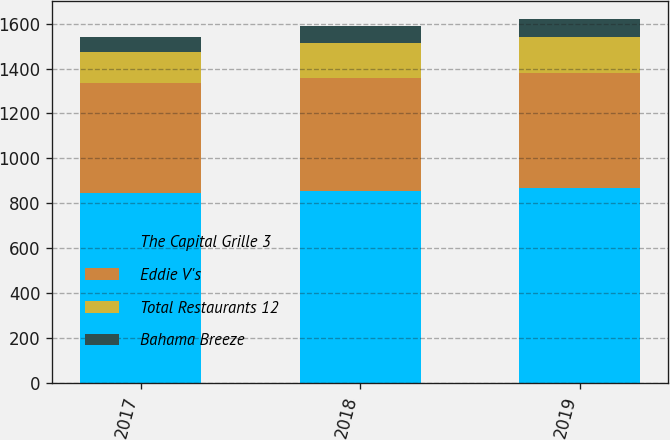<chart> <loc_0><loc_0><loc_500><loc_500><stacked_bar_chart><ecel><fcel>2017<fcel>2018<fcel>2019<nl><fcel>The Capital Grille 3<fcel>846<fcel>856<fcel>866<nl><fcel>Eddie V's<fcel>490<fcel>504<fcel>514<nl><fcel>Total Restaurants 12<fcel>140<fcel>156<fcel>161<nl><fcel>Bahama Breeze<fcel>67<fcel>72<fcel>79<nl></chart> 